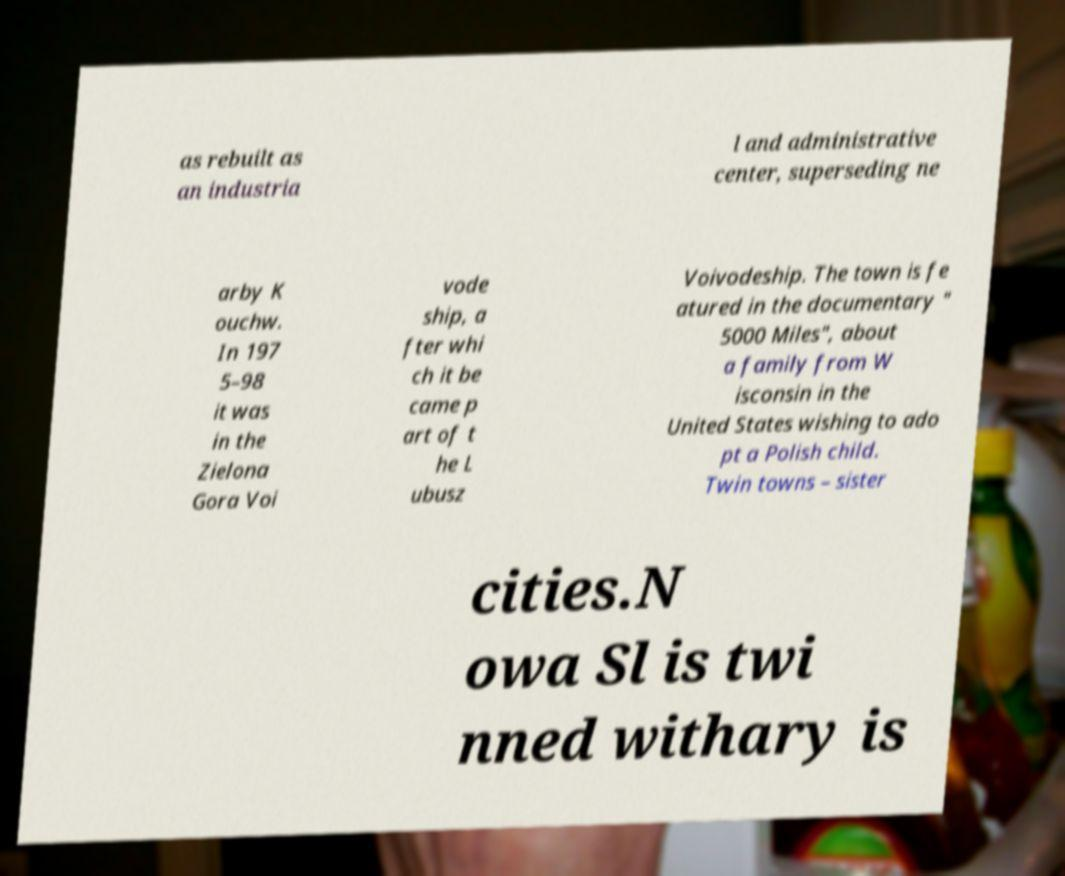For documentation purposes, I need the text within this image transcribed. Could you provide that? as rebuilt as an industria l and administrative center, superseding ne arby K ouchw. In 197 5–98 it was in the Zielona Gora Voi vode ship, a fter whi ch it be came p art of t he L ubusz Voivodeship. The town is fe atured in the documentary " 5000 Miles", about a family from W isconsin in the United States wishing to ado pt a Polish child. Twin towns – sister cities.N owa Sl is twi nned withary is 